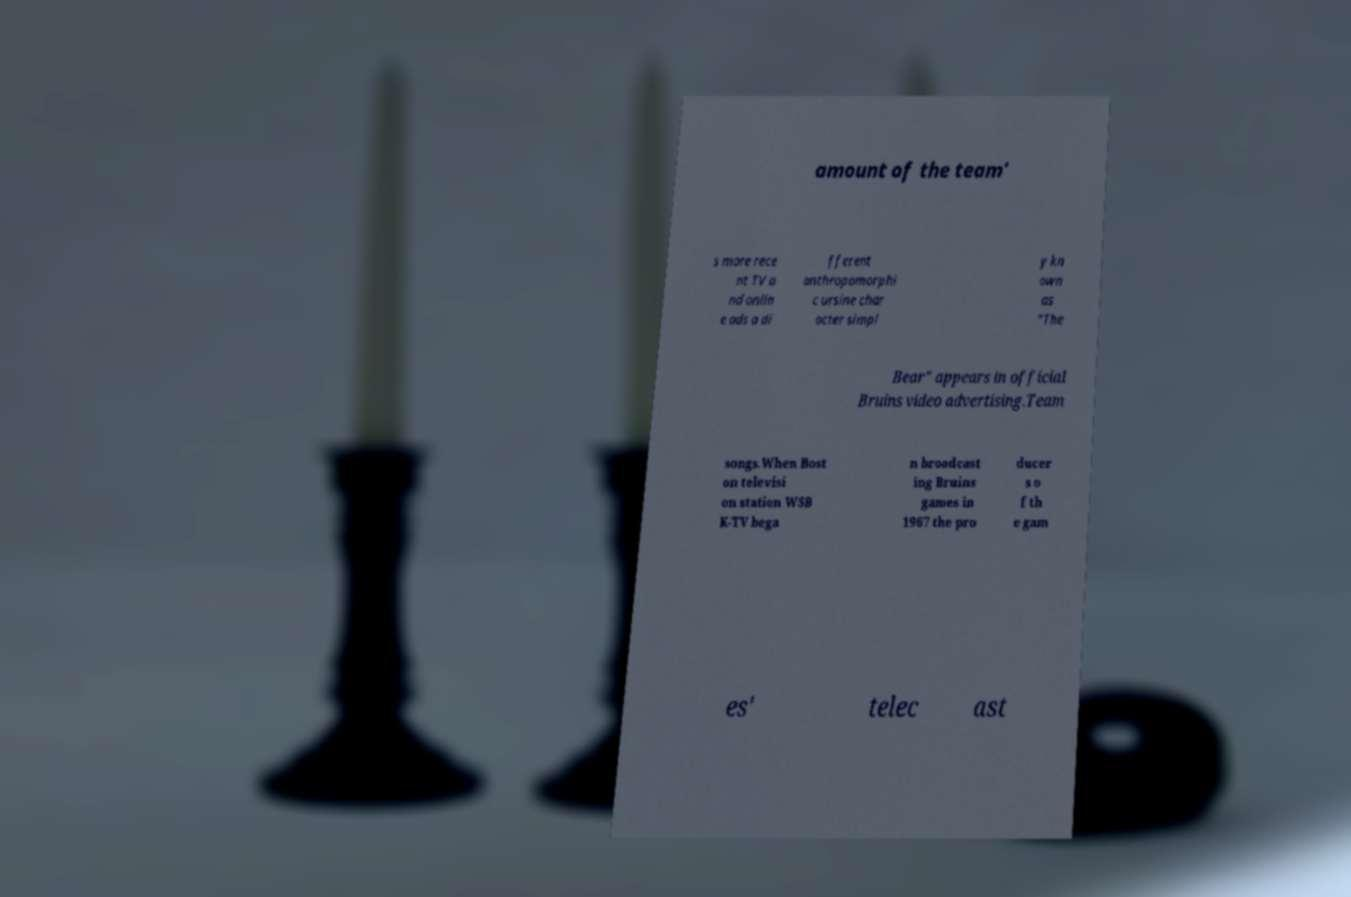What messages or text are displayed in this image? I need them in a readable, typed format. amount of the team' s more rece nt TV a nd onlin e ads a di fferent anthropomorphi c ursine char acter simpl y kn own as "The Bear" appears in official Bruins video advertising.Team songs.When Bost on televisi on station WSB K-TV bega n broadcast ing Bruins games in 1967 the pro ducer s o f th e gam es' telec ast 